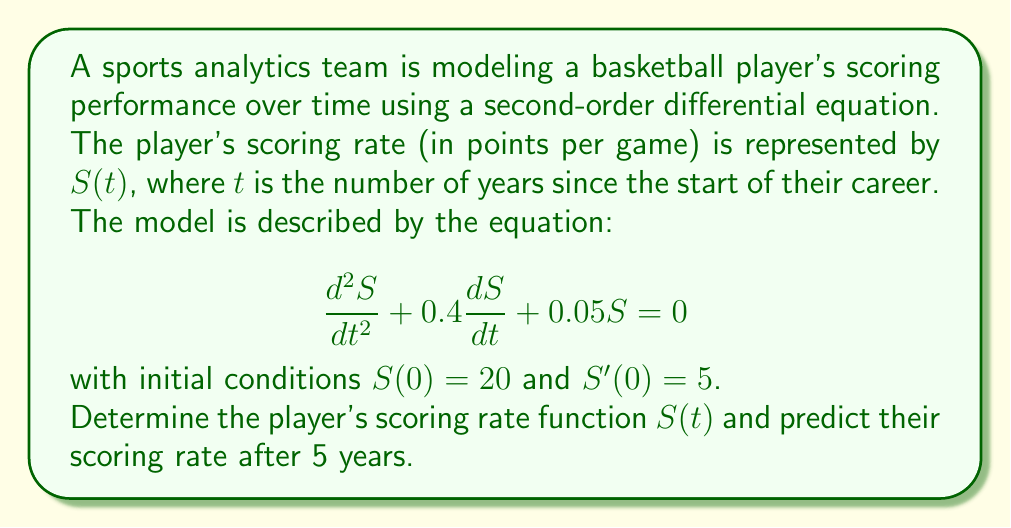Provide a solution to this math problem. To solve this problem, we'll follow these steps:

1) First, we need to find the general solution to the homogeneous second-order differential equation.

2) The characteristic equation for this differential equation is:
   $r^2 + 0.4r + 0.05 = 0$

3) Solving this quadratic equation:
   $r = \frac{-0.4 \pm \sqrt{0.4^2 - 4(1)(0.05)}}{2(1)} = \frac{-0.4 \pm \sqrt{0.16 - 0.2}}{2} = \frac{-0.4 \pm \sqrt{-0.04}}{2}$

4) This gives us complex roots: $r = -0.2 \pm 0.1i$

5) Therefore, the general solution has the form:
   $S(t) = e^{-0.2t}(A\cos(0.1t) + B\sin(0.1t))$

6) Now we use the initial conditions to find $A$ and $B$:
   $S(0) = 20$, so $A = 20$
   $S'(0) = 5$, so $-0.2A + 0.1B = 5$
   Substituting $A = 20$: $-4 + 0.1B = 5$, so $B = 90$

7) Thus, the specific solution is:
   $S(t) = e^{-0.2t}(20\cos(0.1t) + 90\sin(0.1t))$

8) To find the scoring rate after 5 years, we evaluate $S(5)$:
   $S(5) = e^{-1}(20\cos(0.5) + 90\sin(0.5))$
   $\approx 0.368 * (20 * 0.878 + 90 * 0.479)$
   $\approx 0.368 * (17.56 + 43.11)$
   $\approx 22.33$
Answer: The player's scoring rate function is $S(t) = e^{-0.2t}(20\cos(0.1t) + 90\sin(0.1t))$, and their predicted scoring rate after 5 years is approximately 22.33 points per game. 